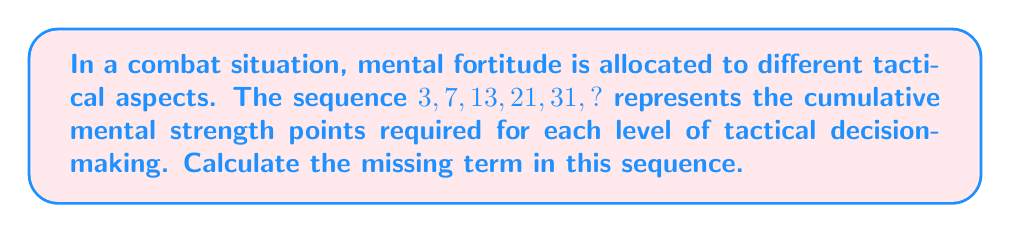Teach me how to tackle this problem. To solve this problem, we need to identify the pattern in the sequence:

1) First, let's calculate the differences between consecutive terms:
   $7 - 3 = 4$
   $13 - 7 = 6$
   $21 - 13 = 8$
   $31 - 21 = 10$

2) We observe that the differences form an arithmetic sequence: 4, 6, 8, 10
   The common difference of this arithmetic sequence is 2.

3) Therefore, the next difference should be 12:
   $10 + 2 = 12$

4) To find the missing term, we add this difference to the last given term:
   $31 + 12 = 43$

5) Let's verify the pattern:
   $3 + 4 = 7$
   $7 + 6 = 13$
   $13 + 8 = 21$
   $21 + 10 = 31$
   $31 + 12 = 43$

Thus, the missing term in the sequence is 43.
Answer: 43 